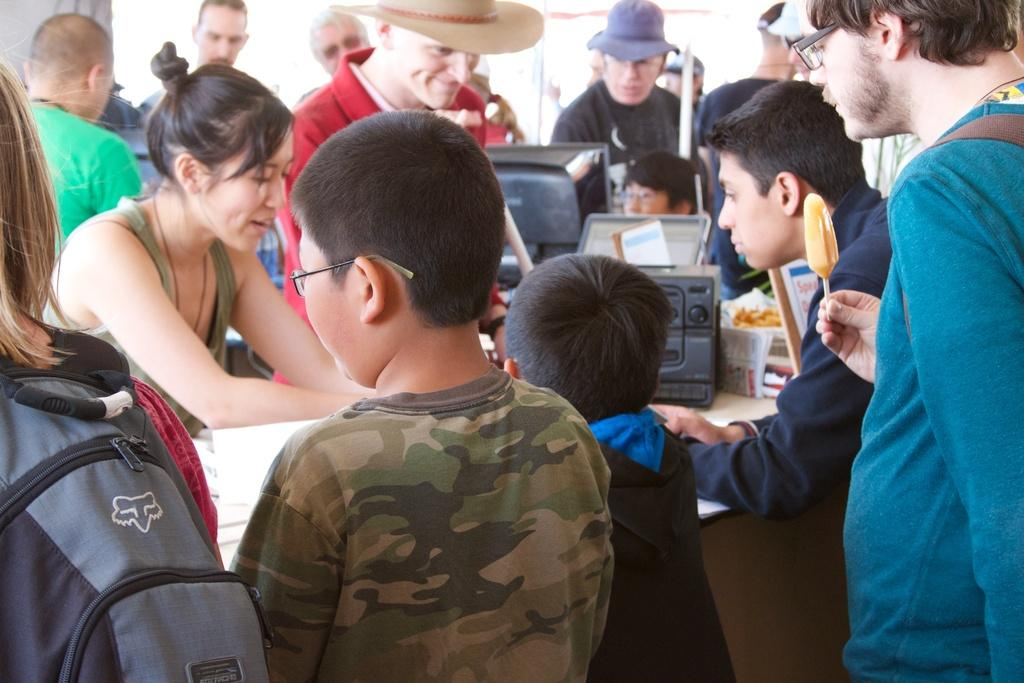How many people are in the image? There is a group of people in the image, but the exact number is not specified. What are the people doing in the image? The people are standing around a table. What can be found on the table in the image? There are things on the table, but their specific nature is not mentioned. What type of guide is the dad holding in the image? There is no mention of a guide or a dad in the image, so this question cannot be answered. 